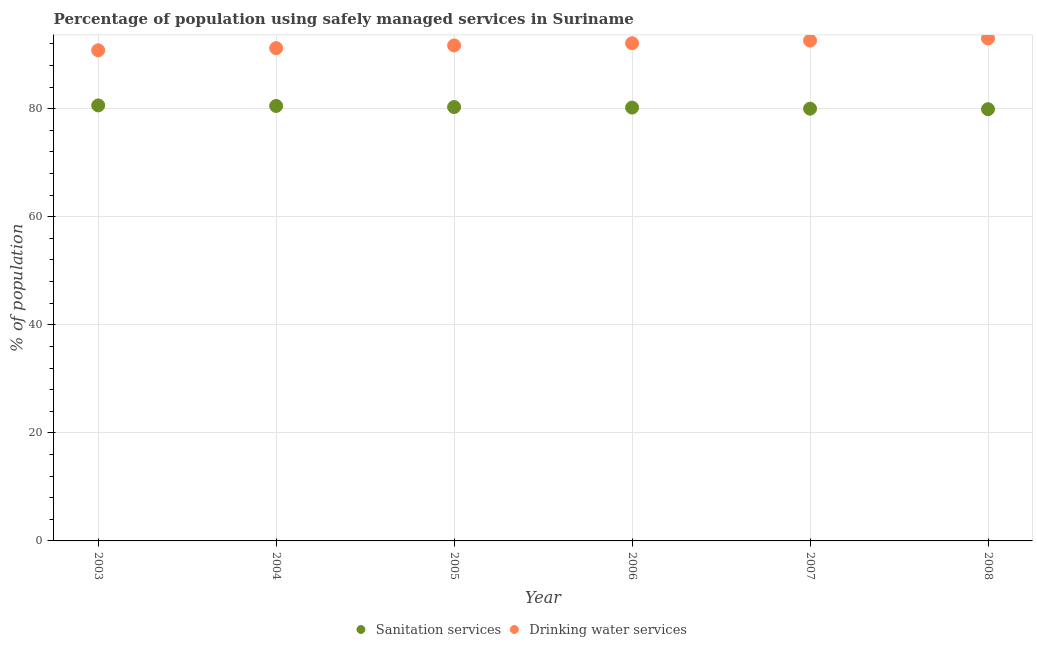How many different coloured dotlines are there?
Ensure brevity in your answer.  2. Is the number of dotlines equal to the number of legend labels?
Provide a short and direct response. Yes. What is the percentage of population who used sanitation services in 2005?
Your response must be concise. 80.3. Across all years, what is the maximum percentage of population who used drinking water services?
Offer a very short reply. 93. Across all years, what is the minimum percentage of population who used drinking water services?
Your answer should be compact. 90.8. In which year was the percentage of population who used sanitation services maximum?
Your answer should be compact. 2003. In which year was the percentage of population who used drinking water services minimum?
Keep it short and to the point. 2003. What is the total percentage of population who used sanitation services in the graph?
Your response must be concise. 481.5. What is the difference between the percentage of population who used sanitation services in 2004 and that in 2006?
Ensure brevity in your answer.  0.3. What is the difference between the percentage of population who used sanitation services in 2003 and the percentage of population who used drinking water services in 2007?
Give a very brief answer. -12. What is the average percentage of population who used drinking water services per year?
Your answer should be very brief. 91.9. In the year 2005, what is the difference between the percentage of population who used sanitation services and percentage of population who used drinking water services?
Provide a succinct answer. -11.4. What is the ratio of the percentage of population who used sanitation services in 2004 to that in 2005?
Ensure brevity in your answer.  1. Is the percentage of population who used sanitation services in 2004 less than that in 2005?
Keep it short and to the point. No. What is the difference between the highest and the second highest percentage of population who used sanitation services?
Provide a succinct answer. 0.1. What is the difference between the highest and the lowest percentage of population who used drinking water services?
Offer a terse response. 2.2. In how many years, is the percentage of population who used sanitation services greater than the average percentage of population who used sanitation services taken over all years?
Provide a succinct answer. 3. Is the percentage of population who used drinking water services strictly greater than the percentage of population who used sanitation services over the years?
Offer a terse response. Yes. How many dotlines are there?
Ensure brevity in your answer.  2. What is the difference between two consecutive major ticks on the Y-axis?
Ensure brevity in your answer.  20. Are the values on the major ticks of Y-axis written in scientific E-notation?
Offer a terse response. No. Does the graph contain grids?
Provide a succinct answer. Yes. How many legend labels are there?
Your answer should be very brief. 2. What is the title of the graph?
Your answer should be very brief. Percentage of population using safely managed services in Suriname. What is the label or title of the X-axis?
Ensure brevity in your answer.  Year. What is the label or title of the Y-axis?
Your response must be concise. % of population. What is the % of population in Sanitation services in 2003?
Make the answer very short. 80.6. What is the % of population in Drinking water services in 2003?
Keep it short and to the point. 90.8. What is the % of population of Sanitation services in 2004?
Give a very brief answer. 80.5. What is the % of population of Drinking water services in 2004?
Your answer should be very brief. 91.2. What is the % of population in Sanitation services in 2005?
Make the answer very short. 80.3. What is the % of population of Drinking water services in 2005?
Give a very brief answer. 91.7. What is the % of population of Sanitation services in 2006?
Offer a very short reply. 80.2. What is the % of population in Drinking water services in 2006?
Your answer should be compact. 92.1. What is the % of population in Sanitation services in 2007?
Offer a very short reply. 80. What is the % of population in Drinking water services in 2007?
Provide a short and direct response. 92.6. What is the % of population of Sanitation services in 2008?
Provide a short and direct response. 79.9. What is the % of population of Drinking water services in 2008?
Ensure brevity in your answer.  93. Across all years, what is the maximum % of population of Sanitation services?
Your answer should be very brief. 80.6. Across all years, what is the maximum % of population of Drinking water services?
Your answer should be compact. 93. Across all years, what is the minimum % of population of Sanitation services?
Provide a short and direct response. 79.9. Across all years, what is the minimum % of population of Drinking water services?
Offer a very short reply. 90.8. What is the total % of population in Sanitation services in the graph?
Your answer should be very brief. 481.5. What is the total % of population in Drinking water services in the graph?
Keep it short and to the point. 551.4. What is the difference between the % of population in Sanitation services in 2003 and that in 2007?
Give a very brief answer. 0.6. What is the difference between the % of population in Drinking water services in 2003 and that in 2007?
Your answer should be compact. -1.8. What is the difference between the % of population in Sanitation services in 2003 and that in 2008?
Your response must be concise. 0.7. What is the difference between the % of population of Sanitation services in 2004 and that in 2005?
Your answer should be compact. 0.2. What is the difference between the % of population of Sanitation services in 2004 and that in 2006?
Your response must be concise. 0.3. What is the difference between the % of population in Drinking water services in 2004 and that in 2006?
Offer a terse response. -0.9. What is the difference between the % of population in Drinking water services in 2004 and that in 2007?
Give a very brief answer. -1.4. What is the difference between the % of population in Sanitation services in 2004 and that in 2008?
Offer a terse response. 0.6. What is the difference between the % of population of Sanitation services in 2005 and that in 2006?
Ensure brevity in your answer.  0.1. What is the difference between the % of population in Drinking water services in 2005 and that in 2006?
Your response must be concise. -0.4. What is the difference between the % of population of Drinking water services in 2005 and that in 2007?
Give a very brief answer. -0.9. What is the difference between the % of population in Drinking water services in 2006 and that in 2007?
Keep it short and to the point. -0.5. What is the difference between the % of population of Sanitation services in 2003 and the % of population of Drinking water services in 2006?
Provide a succinct answer. -11.5. What is the difference between the % of population of Sanitation services in 2003 and the % of population of Drinking water services in 2007?
Make the answer very short. -12. What is the difference between the % of population of Sanitation services in 2007 and the % of population of Drinking water services in 2008?
Make the answer very short. -13. What is the average % of population in Sanitation services per year?
Give a very brief answer. 80.25. What is the average % of population in Drinking water services per year?
Your response must be concise. 91.9. In the year 2006, what is the difference between the % of population in Sanitation services and % of population in Drinking water services?
Ensure brevity in your answer.  -11.9. In the year 2008, what is the difference between the % of population in Sanitation services and % of population in Drinking water services?
Ensure brevity in your answer.  -13.1. What is the ratio of the % of population of Sanitation services in 2003 to that in 2004?
Ensure brevity in your answer.  1. What is the ratio of the % of population in Drinking water services in 2003 to that in 2004?
Your response must be concise. 1. What is the ratio of the % of population in Sanitation services in 2003 to that in 2005?
Offer a terse response. 1. What is the ratio of the % of population in Drinking water services in 2003 to that in 2005?
Your answer should be very brief. 0.99. What is the ratio of the % of population of Drinking water services in 2003 to that in 2006?
Your answer should be compact. 0.99. What is the ratio of the % of population in Sanitation services in 2003 to that in 2007?
Keep it short and to the point. 1.01. What is the ratio of the % of population in Drinking water services in 2003 to that in 2007?
Give a very brief answer. 0.98. What is the ratio of the % of population of Sanitation services in 2003 to that in 2008?
Provide a short and direct response. 1.01. What is the ratio of the % of population in Drinking water services in 2003 to that in 2008?
Keep it short and to the point. 0.98. What is the ratio of the % of population of Sanitation services in 2004 to that in 2005?
Provide a succinct answer. 1. What is the ratio of the % of population of Drinking water services in 2004 to that in 2005?
Offer a terse response. 0.99. What is the ratio of the % of population of Sanitation services in 2004 to that in 2006?
Keep it short and to the point. 1. What is the ratio of the % of population of Drinking water services in 2004 to that in 2006?
Provide a short and direct response. 0.99. What is the ratio of the % of population of Drinking water services in 2004 to that in 2007?
Your response must be concise. 0.98. What is the ratio of the % of population of Sanitation services in 2004 to that in 2008?
Give a very brief answer. 1.01. What is the ratio of the % of population in Drinking water services in 2004 to that in 2008?
Provide a short and direct response. 0.98. What is the ratio of the % of population of Sanitation services in 2005 to that in 2006?
Your answer should be compact. 1. What is the ratio of the % of population in Sanitation services in 2005 to that in 2007?
Provide a succinct answer. 1. What is the ratio of the % of population in Drinking water services in 2005 to that in 2007?
Provide a succinct answer. 0.99. What is the ratio of the % of population of Drinking water services in 2005 to that in 2008?
Keep it short and to the point. 0.99. What is the ratio of the % of population in Sanitation services in 2006 to that in 2008?
Offer a very short reply. 1. What is the ratio of the % of population in Drinking water services in 2006 to that in 2008?
Give a very brief answer. 0.99. What is the difference between the highest and the second highest % of population of Drinking water services?
Offer a very short reply. 0.4. What is the difference between the highest and the lowest % of population of Drinking water services?
Your answer should be compact. 2.2. 